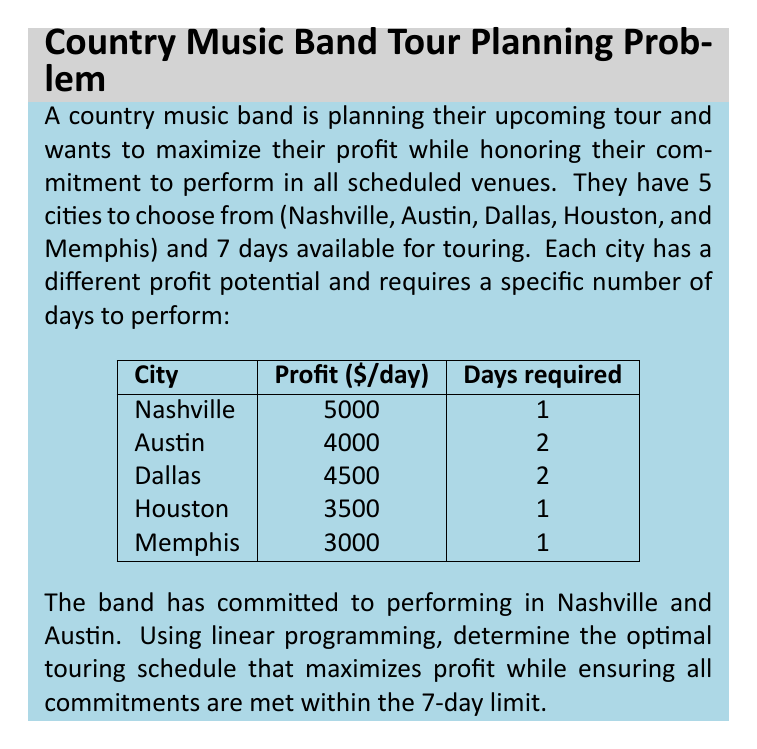Show me your answer to this math problem. Let's approach this problem using linear programming:

1. Define variables:
   Let $x_i$ be the number of days spent in city $i$, where $i \in \{N, A, D, H, M\}$ for Nashville, Austin, Dallas, Houston, and Memphis respectively.

2. Objective function:
   Maximize profit: $Z = 5000x_N + 4000x_A + 4500x_D + 3500x_H + 3000x_M$

3. Constraints:
   a) Total days constraint: $x_N + x_A + x_D + x_H + x_M \leq 7$
   b) Nashville commitment: $x_N \geq 1$
   c) Austin commitment: $x_A \geq 2$
   d) Days required for each city:
      $x_N \leq 1$, $x_A \leq 2$, $x_D \leq 2$, $x_H \leq 1$, $x_M \leq 1$
   e) Non-negativity: $x_N, x_A, x_D, x_H, x_M \geq 0$

4. Solve using the simplex method or linear programming software:

   The optimal solution is:
   $x_N = 1$, $x_A = 2$, $x_D = 2$, $x_H = 1$, $x_M = 1$

5. Calculate the maximum profit:
   $Z = 5000(1) + 4000(2) + 4500(2) + 3500(1) + 3000(1) = 28,500$

This schedule meets all commitments (Nashville and Austin) and maximizes profit within the 7-day limit.
Answer: The optimal touring schedule is:
Nashville: 1 day
Austin: 2 days
Dallas: 2 days
Houston: 1 day
Memphis: 1 day

Maximum profit: $28,500 